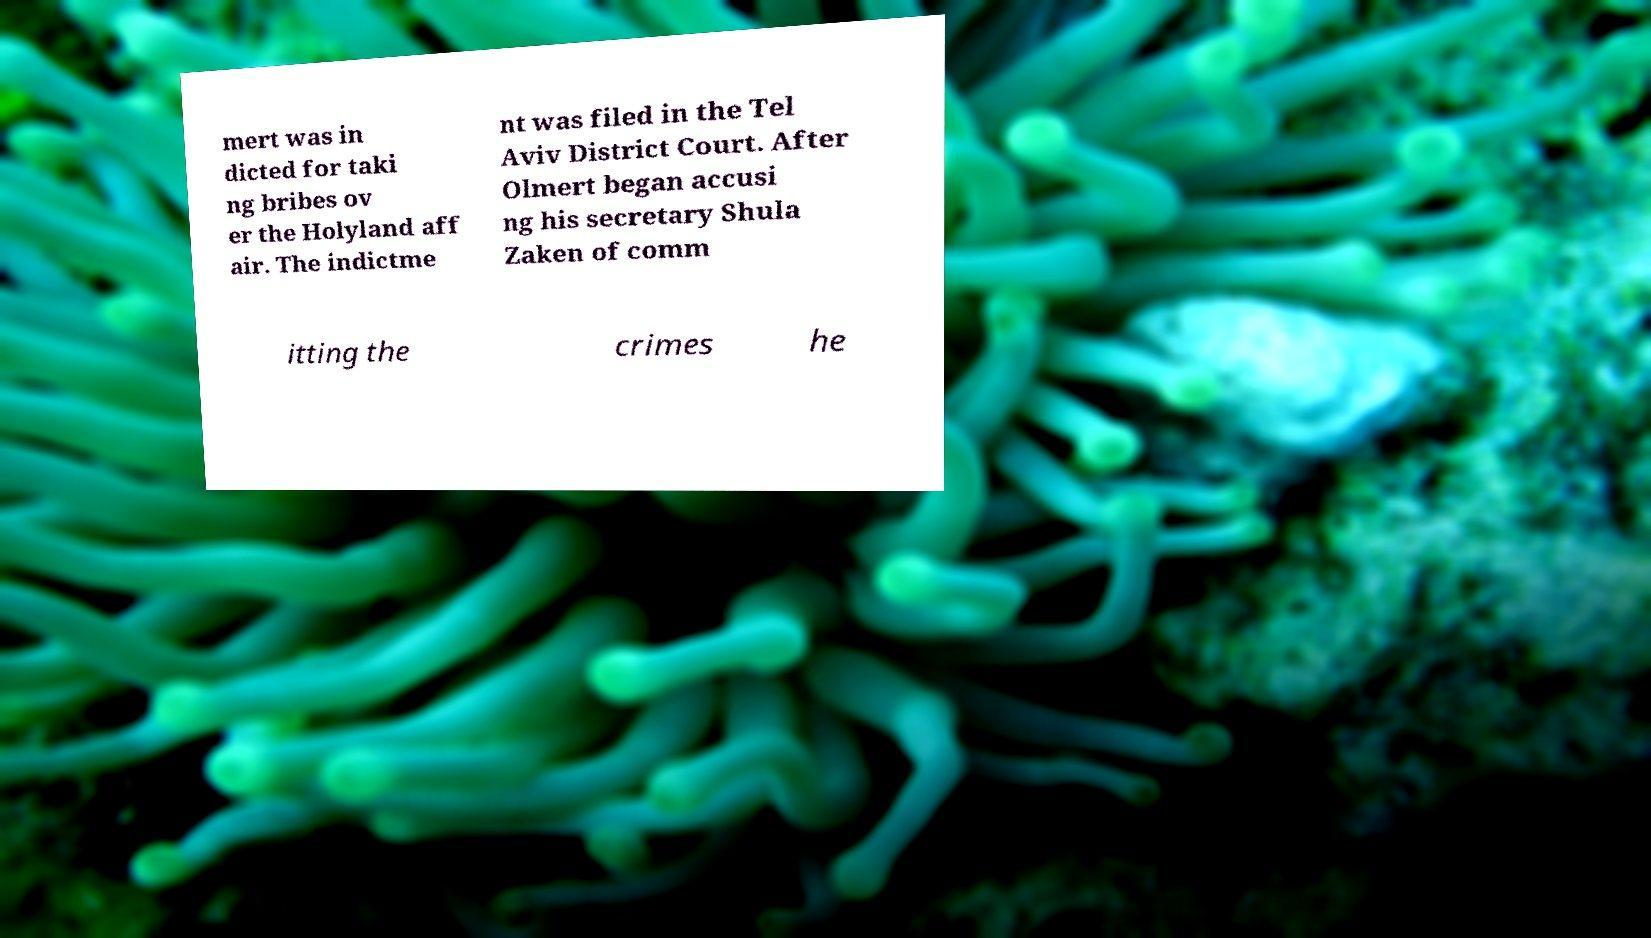I need the written content from this picture converted into text. Can you do that? mert was in dicted for taki ng bribes ov er the Holyland aff air. The indictme nt was filed in the Tel Aviv District Court. After Olmert began accusi ng his secretary Shula Zaken of comm itting the crimes he 